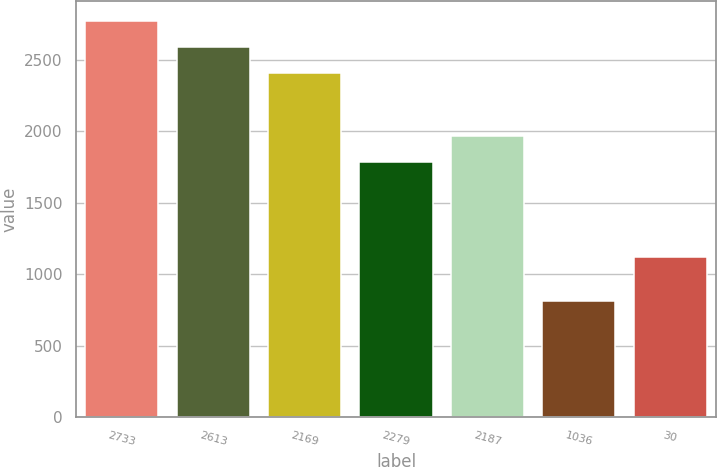Convert chart to OTSL. <chart><loc_0><loc_0><loc_500><loc_500><bar_chart><fcel>2733<fcel>2613<fcel>2169<fcel>2279<fcel>2187<fcel>1036<fcel>30<nl><fcel>2773<fcel>2591.5<fcel>2410<fcel>1785<fcel>1966.5<fcel>816<fcel>1120<nl></chart> 